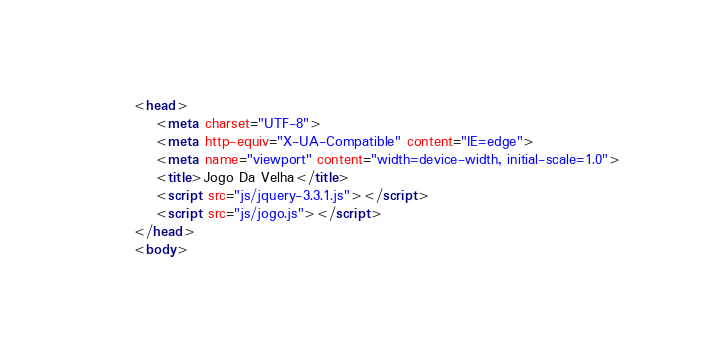Convert code to text. <code><loc_0><loc_0><loc_500><loc_500><_HTML_><head>
    <meta charset="UTF-8">
    <meta http-equiv="X-UA-Compatible" content="IE=edge">
    <meta name="viewport" content="width=device-width, initial-scale=1.0">
    <title>Jogo Da Velha</title>
    <script src="js/jquery-3.3.1.js"></script>
    <script src="js/jogo.js"></script>
</head>
<body></code> 